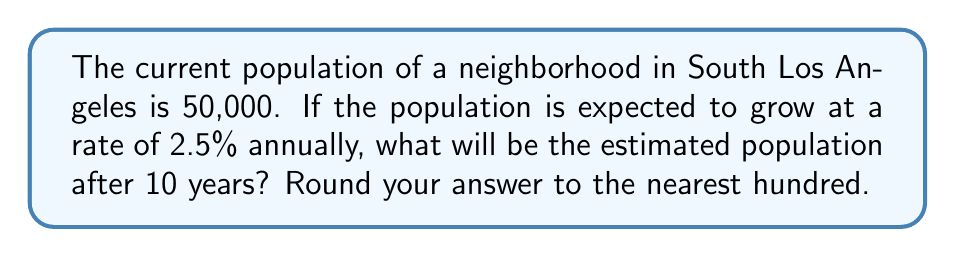What is the answer to this math problem? To solve this problem, we'll use the exponential growth formula:

$$A = P(1 + r)^t$$

Where:
$A$ = Final amount (population after 10 years)
$P$ = Initial amount (current population)
$r$ = Growth rate (as a decimal)
$t$ = Time period (in years)

Given:
$P = 50,000$
$r = 2.5\% = 0.025$
$t = 10$ years

Step 1: Plug the values into the formula
$$A = 50,000(1 + 0.025)^{10}$$

Step 2: Simplify the expression inside the parentheses
$$A = 50,000(1.025)^{10}$$

Step 3: Calculate $(1.025)^{10}$ using a calculator
$(1.025)^{10} \approx 1.2800816$

Step 4: Multiply the result by 50,000
$$A = 50,000 \times 1.2800816 = 64,004.08$$

Step 5: Round to the nearest hundred
$64,004.08 \approx 64,000$

Therefore, the estimated population after 10 years will be 64,000.
Answer: 64,000 